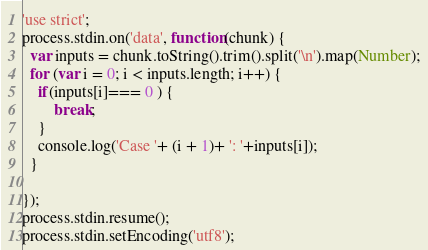Convert code to text. <code><loc_0><loc_0><loc_500><loc_500><_JavaScript_>'use strict';
process.stdin.on('data', function(chunk) {
  var inputs = chunk.toString().trim().split('\n').map(Number);
  for (var i = 0; i < inputs.length; i++) {
    if(inputs[i]=== 0 ) {
        break;
    }
    console.log('Case '+ (i + 1)+ ': '+inputs[i]);
  }
    
});
process.stdin.resume();
process.stdin.setEncoding('utf8');</code> 